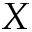<formula> <loc_0><loc_0><loc_500><loc_500>X</formula> 